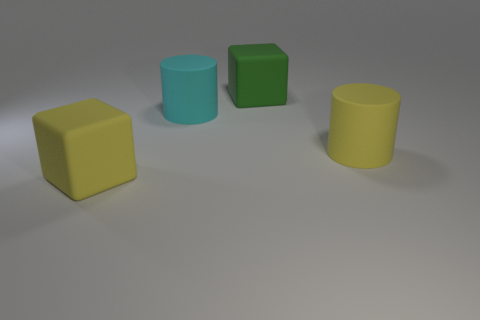There is a big yellow rubber object that is behind the big block that is left of the cyan rubber object; what shape is it?
Make the answer very short. Cylinder. There is a cyan cylinder; does it have the same size as the matte block in front of the green cube?
Give a very brief answer. Yes. What is the material of the thing on the right side of the large green matte cube?
Give a very brief answer. Rubber. What number of matte cubes are behind the large cyan object and on the left side of the large green thing?
Provide a succinct answer. 0. What is the material of the yellow cube that is the same size as the cyan matte thing?
Make the answer very short. Rubber. There is a yellow rubber object that is to the left of the cyan thing; does it have the same size as the thing to the right of the green thing?
Provide a succinct answer. Yes. Are there any big cyan rubber cylinders behind the large green thing?
Make the answer very short. No. The cylinder that is to the left of the cylinder that is on the right side of the green matte thing is what color?
Offer a terse response. Cyan. Is the number of yellow things less than the number of large yellow cylinders?
Your answer should be very brief. No. How many large yellow matte objects have the same shape as the cyan matte thing?
Your response must be concise. 1. 